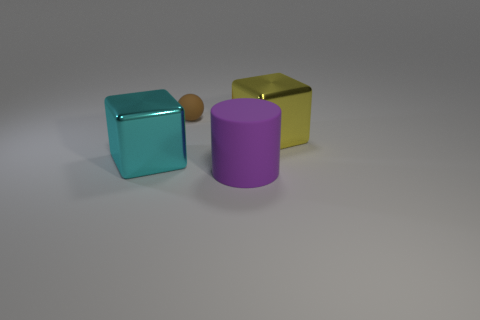Is there anything else that has the same shape as the brown rubber object?
Keep it short and to the point. No. How many other objects are the same color as the rubber cylinder?
Your answer should be very brief. 0. What shape is the large shiny thing to the left of the yellow block?
Offer a very short reply. Cube. What number of matte things are there?
Your answer should be compact. 2. What is the color of the big cylinder that is made of the same material as the brown ball?
Ensure brevity in your answer.  Purple. What number of big things are rubber objects or cylinders?
Offer a terse response. 1. How many large metallic objects are in front of the yellow shiny block?
Offer a terse response. 1. What is the color of the other big metallic object that is the same shape as the large cyan thing?
Offer a terse response. Yellow. What number of metallic things are small things or big cyan cylinders?
Keep it short and to the point. 0. There is a rubber object that is in front of the metallic cube in front of the large yellow cube; are there any big metallic blocks on the right side of it?
Your answer should be very brief. Yes. 